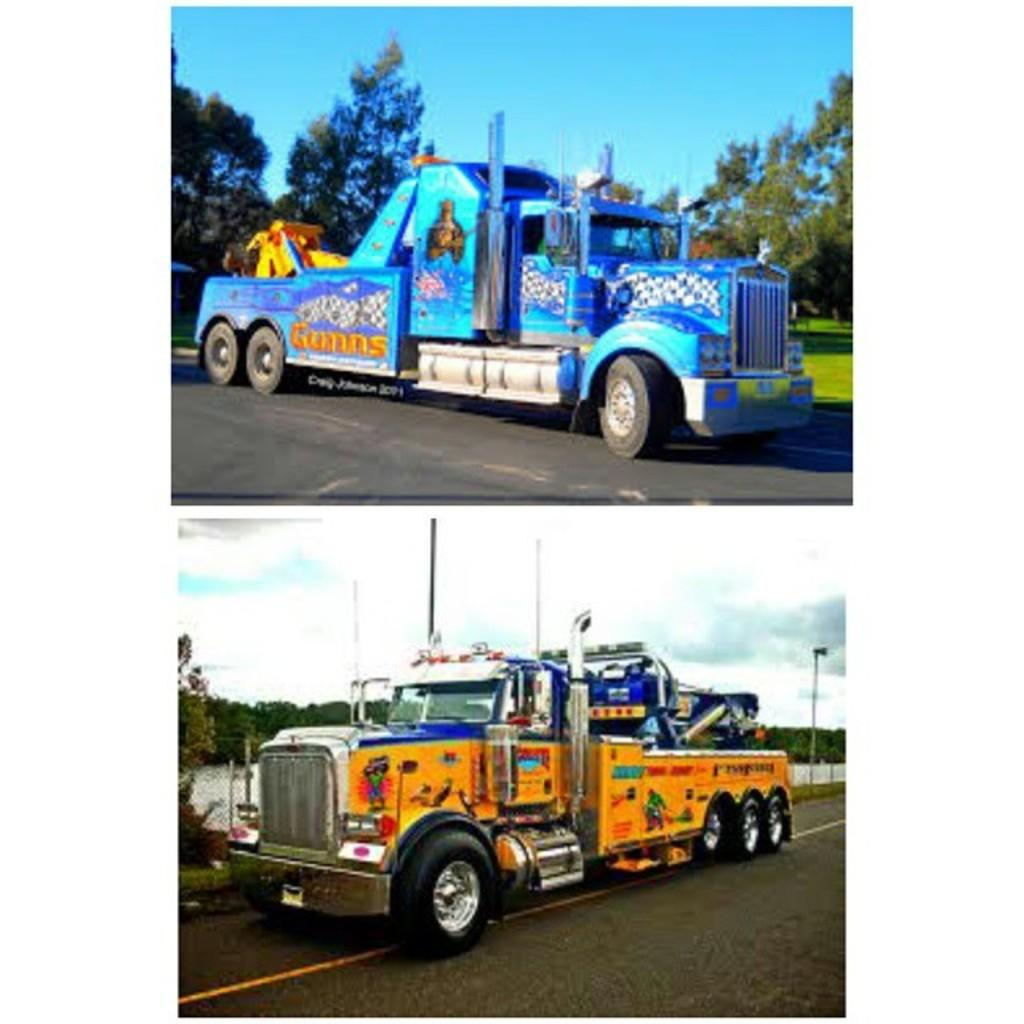How many vehicles can be seen in the image? There are two vehicles in the image. What colors are the vehicles? One vehicle is blue, and the other is yellowish orange. Where are the vehicles located? The vehicles are on the road. What can be seen in the background of the image? There are trees and the sky visible in the background of the image. What book is the vehicle reading in the image? Vehicles do not read books, as they are inanimate objects. 